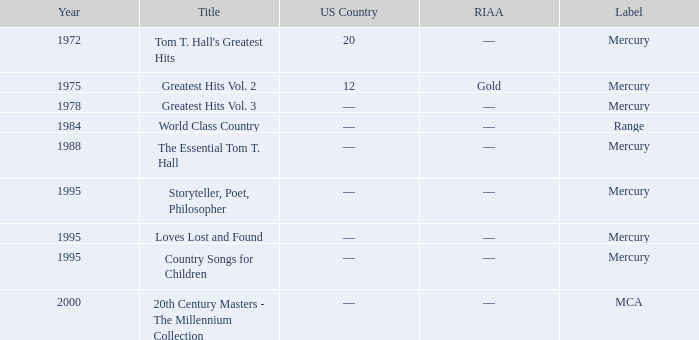What is the title of the album that had a RIAA of gold? Greatest Hits Vol. 2. 